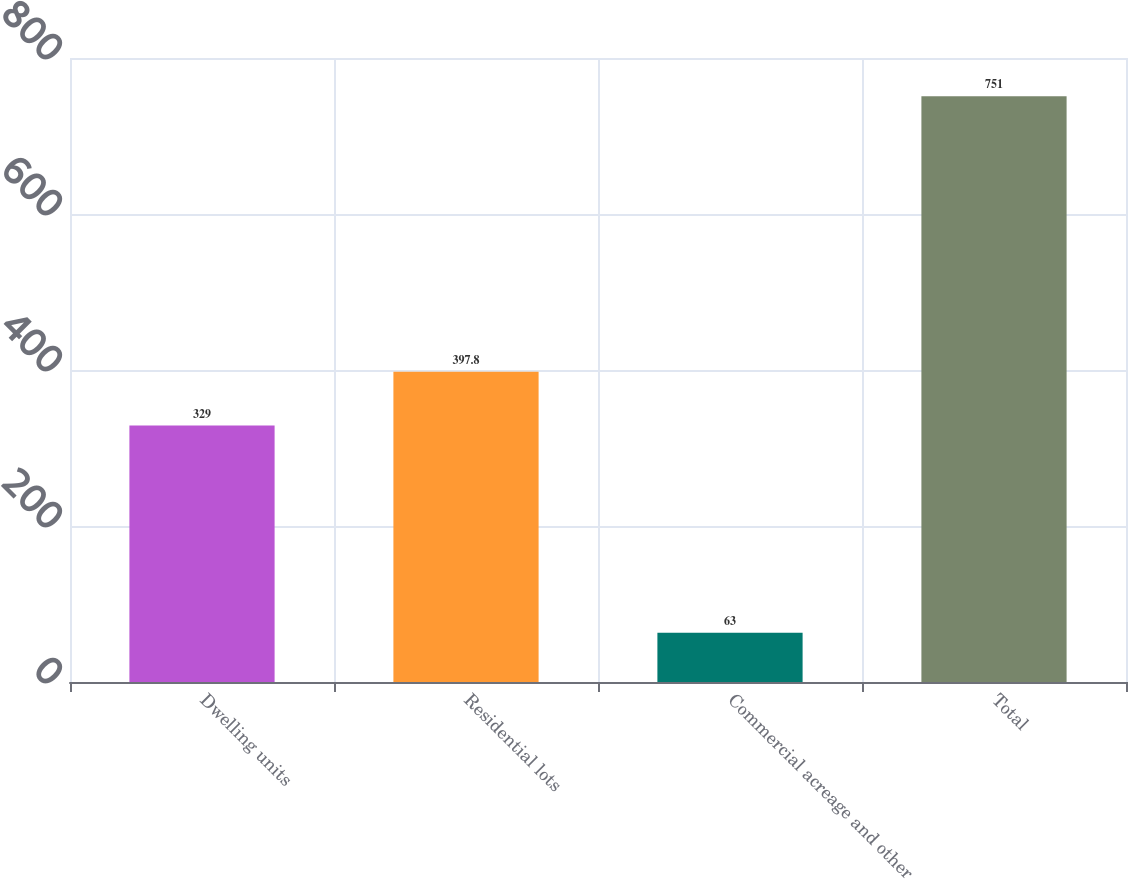Convert chart. <chart><loc_0><loc_0><loc_500><loc_500><bar_chart><fcel>Dwelling units<fcel>Residential lots<fcel>Commercial acreage and other<fcel>Total<nl><fcel>329<fcel>397.8<fcel>63<fcel>751<nl></chart> 